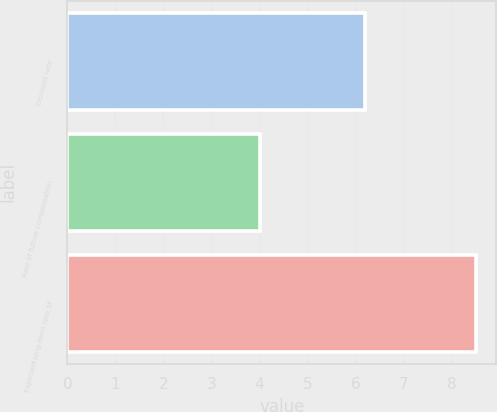Convert chart. <chart><loc_0><loc_0><loc_500><loc_500><bar_chart><fcel>Discount rate<fcel>Rate of future compensation<fcel>Expected long-term rate of<nl><fcel>6.2<fcel>4<fcel>8.5<nl></chart> 